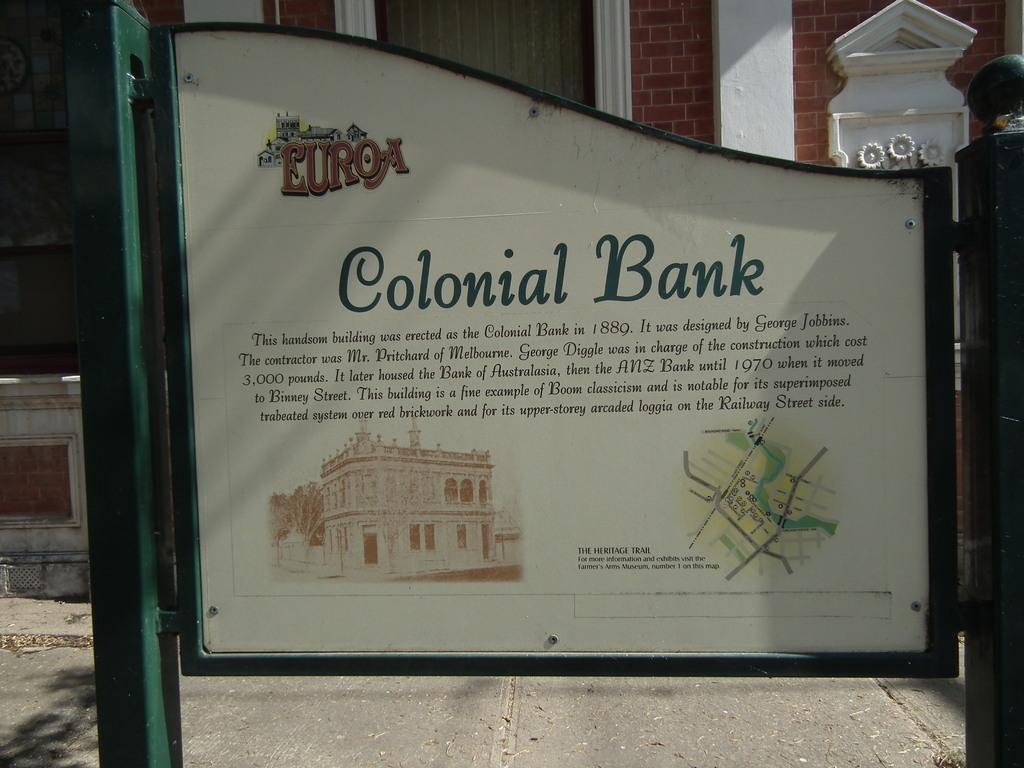Provide a one-sentence caption for the provided image. A sign for the Colonial Bank including a drawing of the building and a map. 